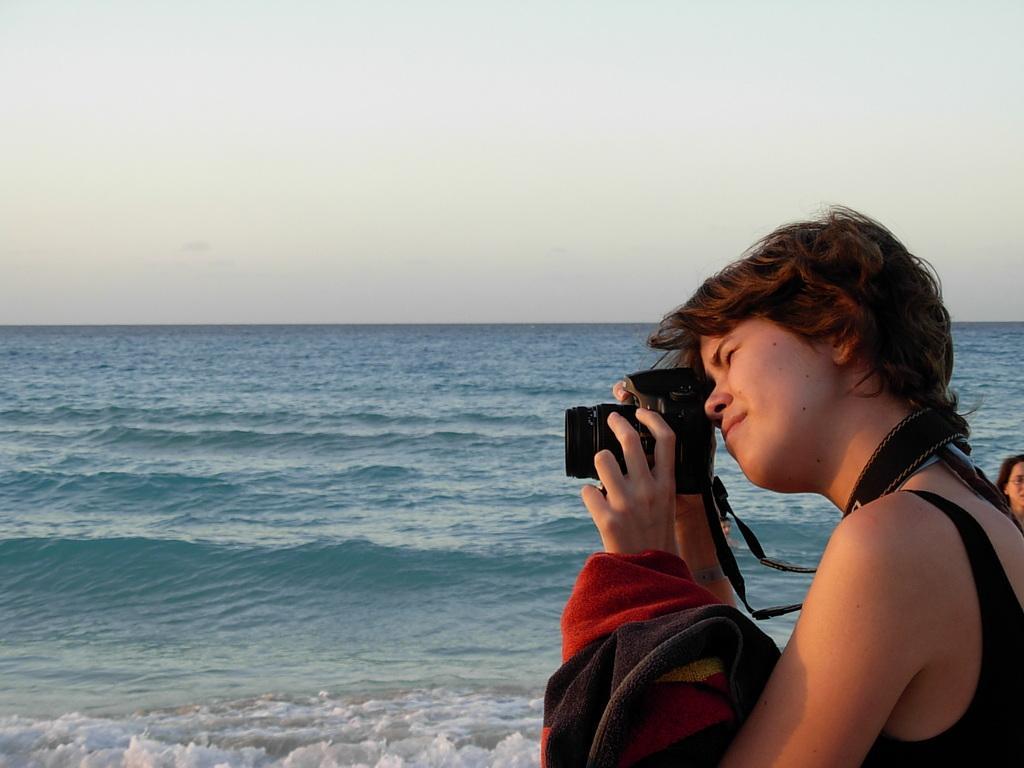Please provide a concise description of this image. This picture shows a woman holding a camera in her hand and a cloth. In the background there is a ocean and a sky here. In the background there is a ocean and a sky here. 